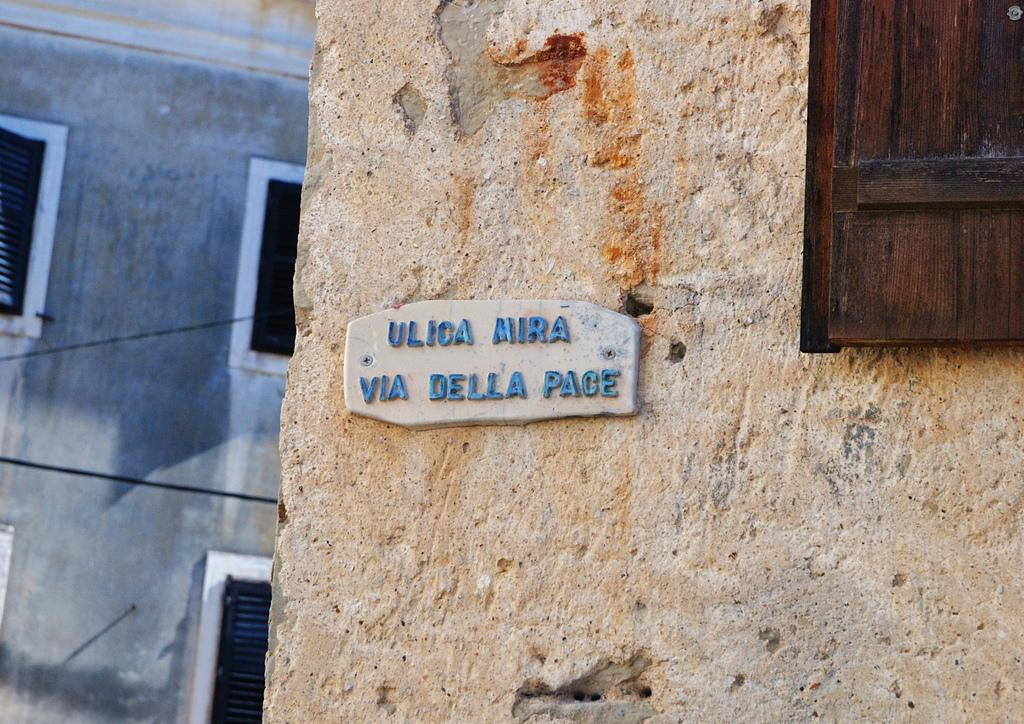What is present on the wall in the image? There is a nameplate on the wall in the image. Can you describe the window in the image? There is a window to the right side of the image. What can be seen in the background of the image? There is a building in the background of the image. What type of fear is depicted in the image? There is no fear depicted in the image; it only features a wall, a nameplate, a window, and a building in the background. What color is the quartz in the image? There is no quartz present in the image. What type of shirt is the person wearing in the image? There is no person or shirt visible in the image. 